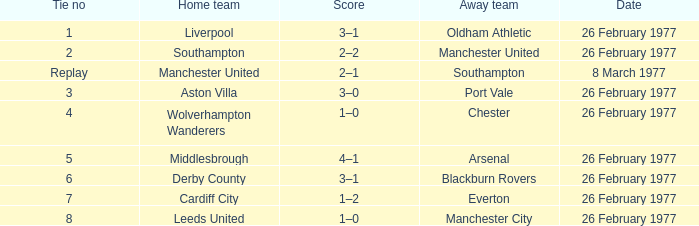What date was Chester the away team? 26 February 1977. 